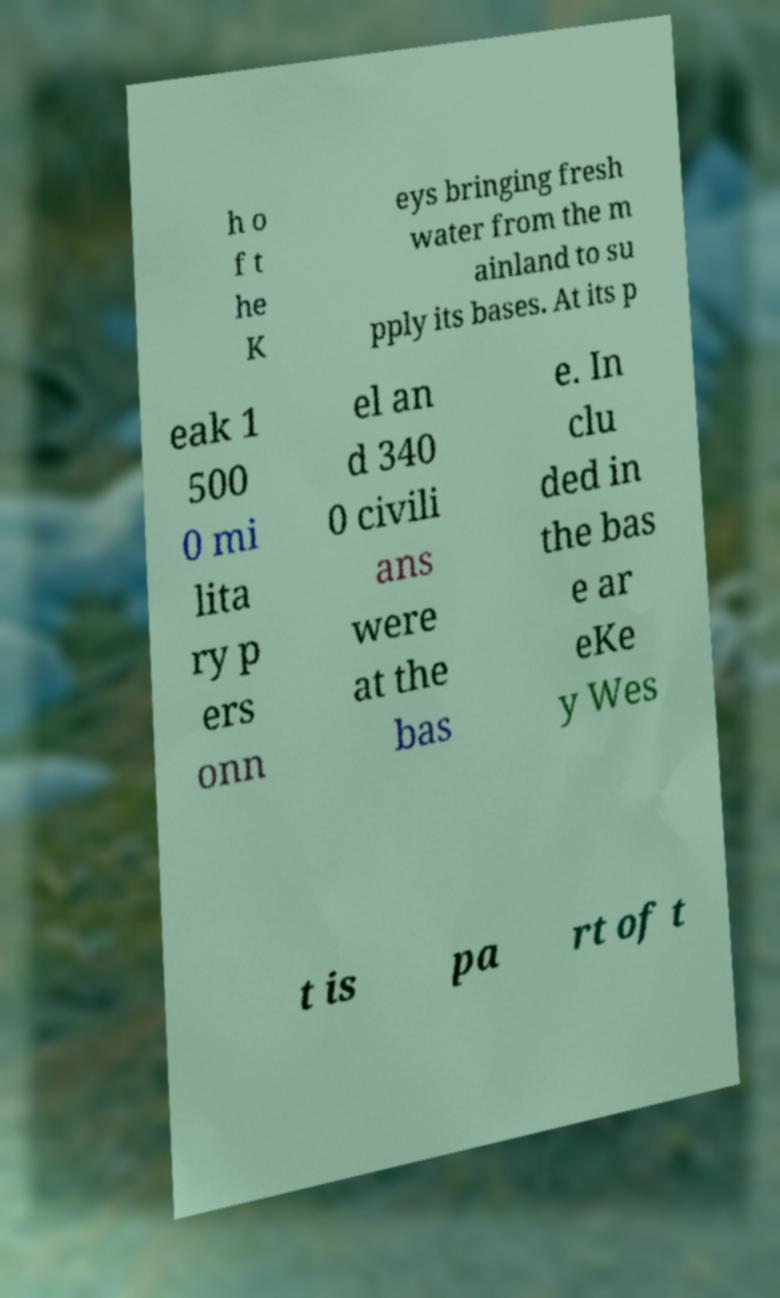Can you accurately transcribe the text from the provided image for me? h o f t he K eys bringing fresh water from the m ainland to su pply its bases. At its p eak 1 500 0 mi lita ry p ers onn el an d 340 0 civili ans were at the bas e. In clu ded in the bas e ar eKe y Wes t is pa rt of t 